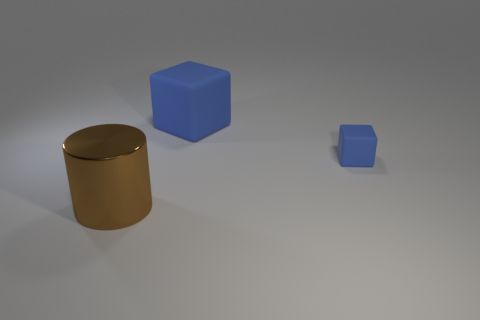Subtract 2 blocks. How many blocks are left? 0 Add 1 gray matte balls. How many objects exist? 4 Subtract all cylinders. How many objects are left? 2 Subtract all cyan blocks. Subtract all red cylinders. How many blocks are left? 2 Subtract all tiny yellow balls. Subtract all brown cylinders. How many objects are left? 2 Add 1 big shiny cylinders. How many big shiny cylinders are left? 2 Add 2 tiny things. How many tiny things exist? 3 Subtract 0 brown balls. How many objects are left? 3 